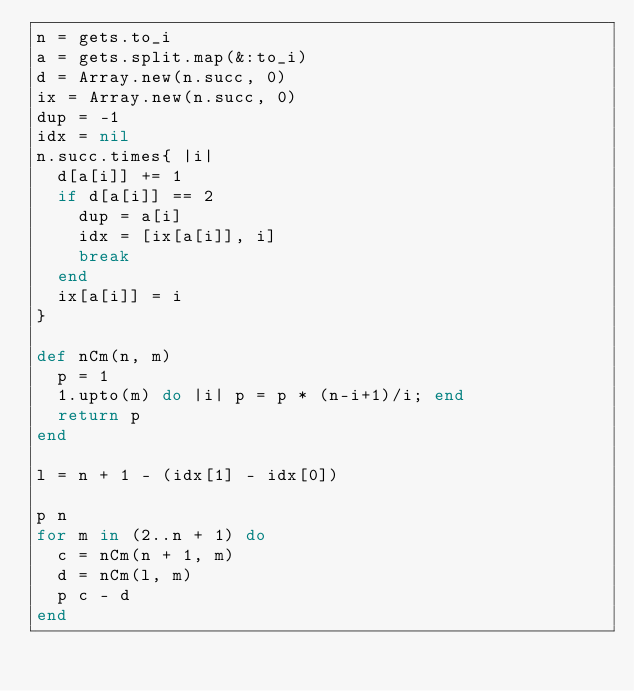Convert code to text. <code><loc_0><loc_0><loc_500><loc_500><_Ruby_>n = gets.to_i
a = gets.split.map(&:to_i)
d = Array.new(n.succ, 0)
ix = Array.new(n.succ, 0)
dup = -1
idx = nil
n.succ.times{ |i|
  d[a[i]] += 1
  if d[a[i]] == 2
    dup = a[i]
    idx = [ix[a[i]], i]
    break
  end
  ix[a[i]] = i
}

def nCm(n, m)
  p = 1
  1.upto(m) do |i| p = p * (n-i+1)/i; end
  return p
end

l = n + 1 - (idx[1] - idx[0])

p n
for m in (2..n + 1) do
  c = nCm(n + 1, m)
  d = nCm(l, m)
  p c - d
end



</code> 